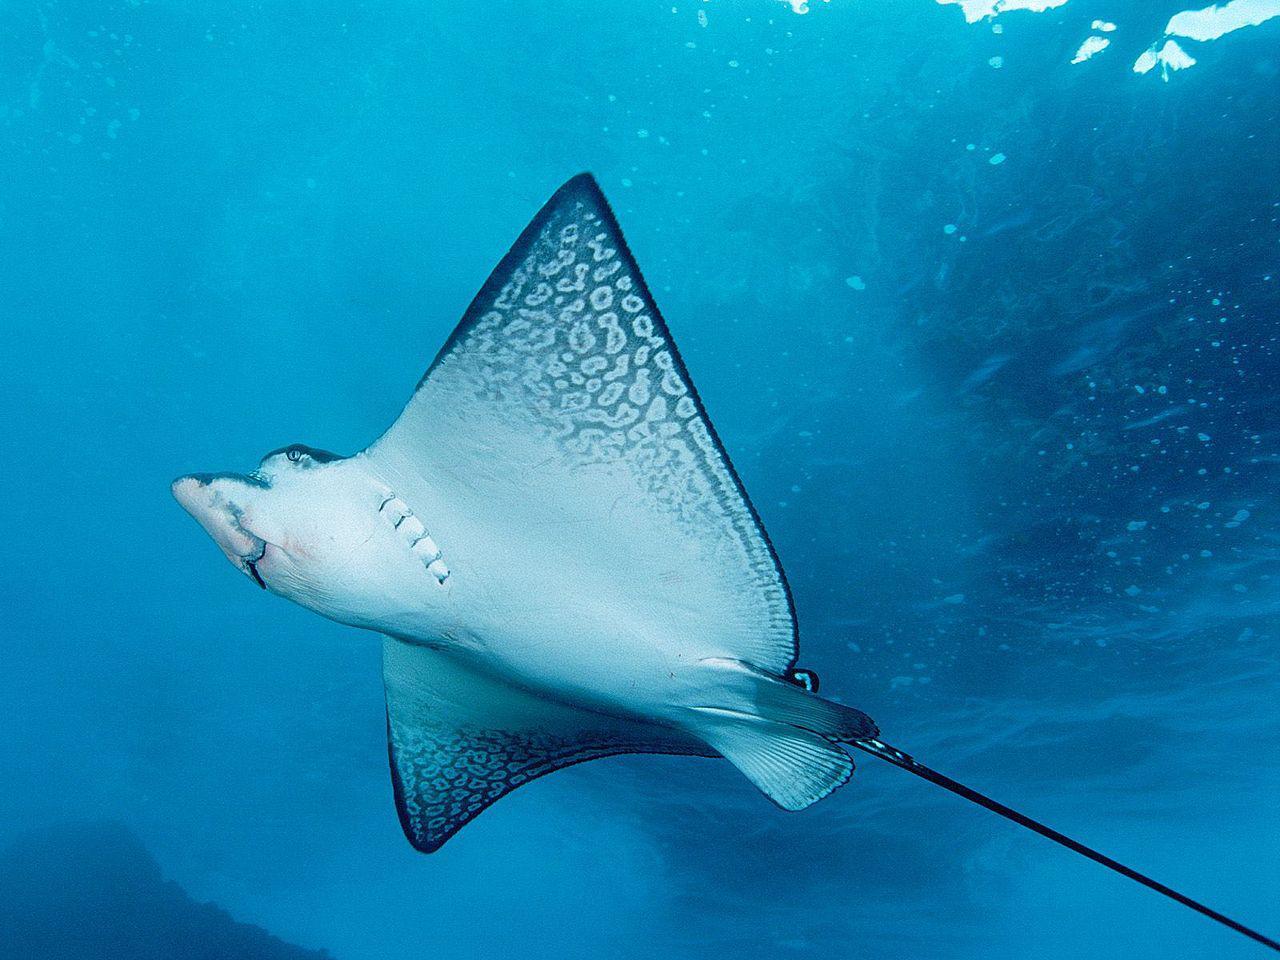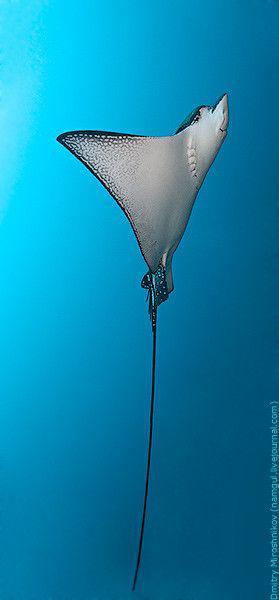The first image is the image on the left, the second image is the image on the right. For the images displayed, is the sentence "There is a group of stingrays in the water." factually correct? Answer yes or no. No. 